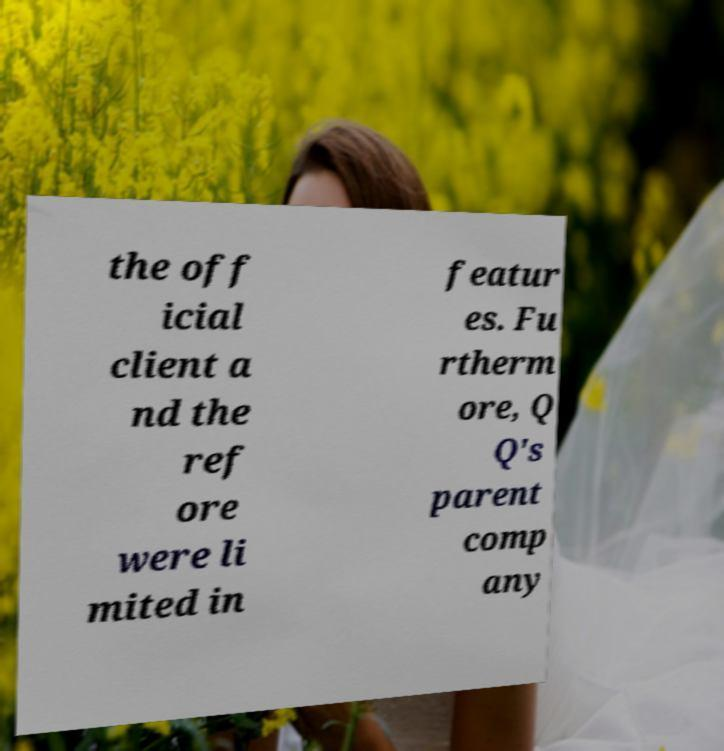Please identify and transcribe the text found in this image. the off icial client a nd the ref ore were li mited in featur es. Fu rtherm ore, Q Q's parent comp any 